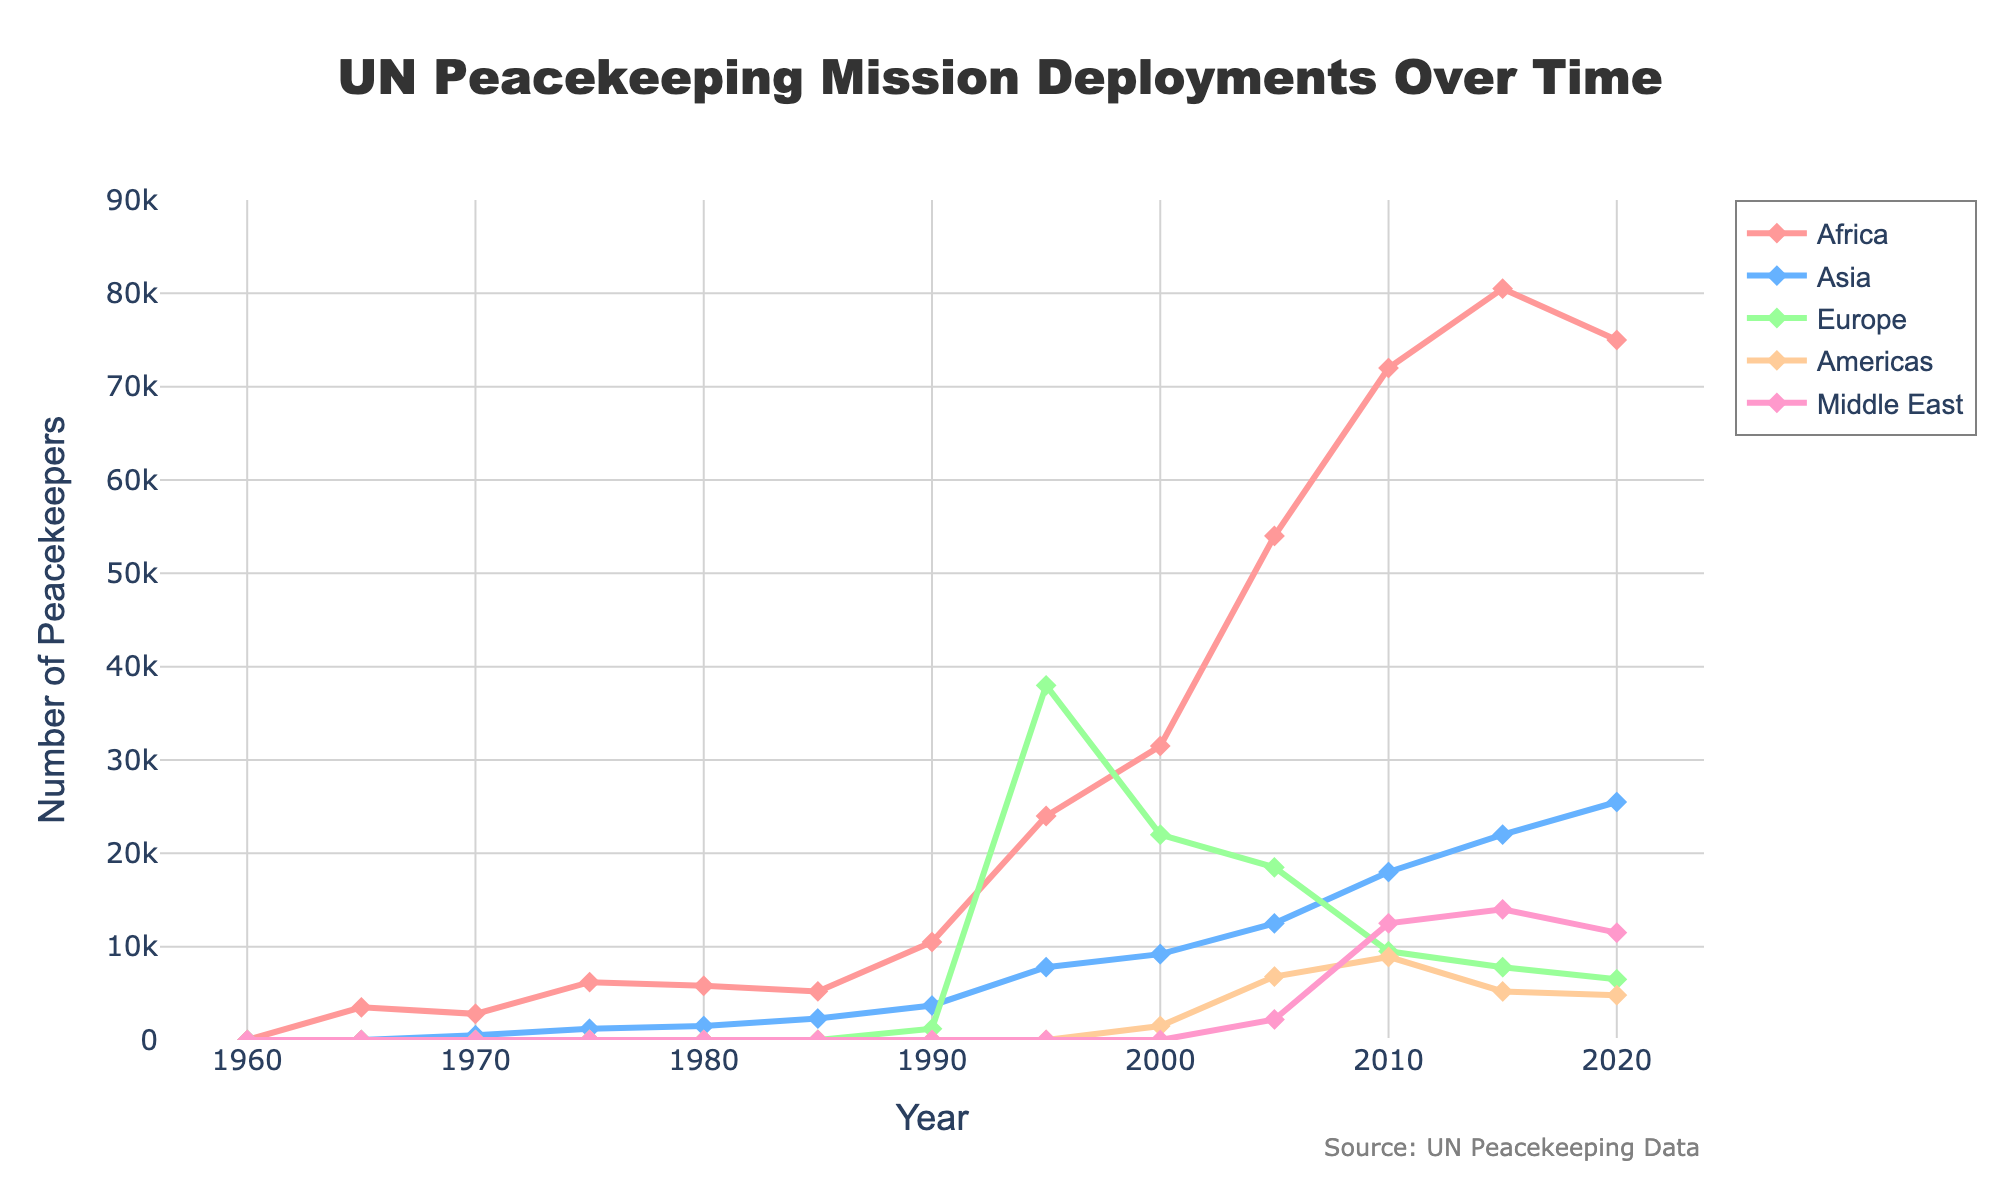What year had the highest number of peacekeepers deployed in Africa? Examine the line for Africa and identify the peak point, which is the highest value on the y-axis. Trace it back to the corresponding year on the x-axis, which occurs at 2015.
Answer: 2015 Which region had the highest number of peacekeepers deployed in 1995? Compare the values for all regions in 1995 and identify the highest. Europe shows the highest value with 38,000 peacekeepers.
Answer: Europe Between 1990 and 2020, which two regions saw an increasing trend in peacekeeper deployments? Observe the trends for each region between 1990 and 2020. Both Asia and Middle East show an upward trend over this period.
Answer: Asia and Middle East What is the average number of peacekeepers deployed in Asia from 2005 to 2015? Sum the values for Asia in 2005, 2010, and 2015, then divide by the number of years (3). (12,500 + 18,000 + 22,000) / 3 = 17,500.
Answer: 17,500 Which region had the least number of peacekeepers in 1980, and what was the number? Check the values for all regions in 1980. Three regions (Europe, Americas, Middle East) had zero peacekeepers, making them the least.
Answer: Europe, Americas, Middle East with 0 How many more peacekeepers were deployed in Africa in 2010 compared to 1985? Find the values for Africa in 2010 and 1985, then subtract the latter from the former. 72,000 (2010) - 5,200 (1985) = 66,800.
Answer: 66,800 In which decade did the Americas first deploy peacekeepers, and how many were deployed? Identify the first non-zero value for the Americas. This happens in the year 2000 with 1,500 peacekeepers, placing it in the 1990s decade.
Answer: 1990s, 1,500 Did Europe ever deploy more peacekeepers than Africa? If yes, in which year? Compare the maximum values of Europe and Africa. In 1995, Europe (38,000) exceeded Africa (24,000).
Answer: Yes, in 1995 